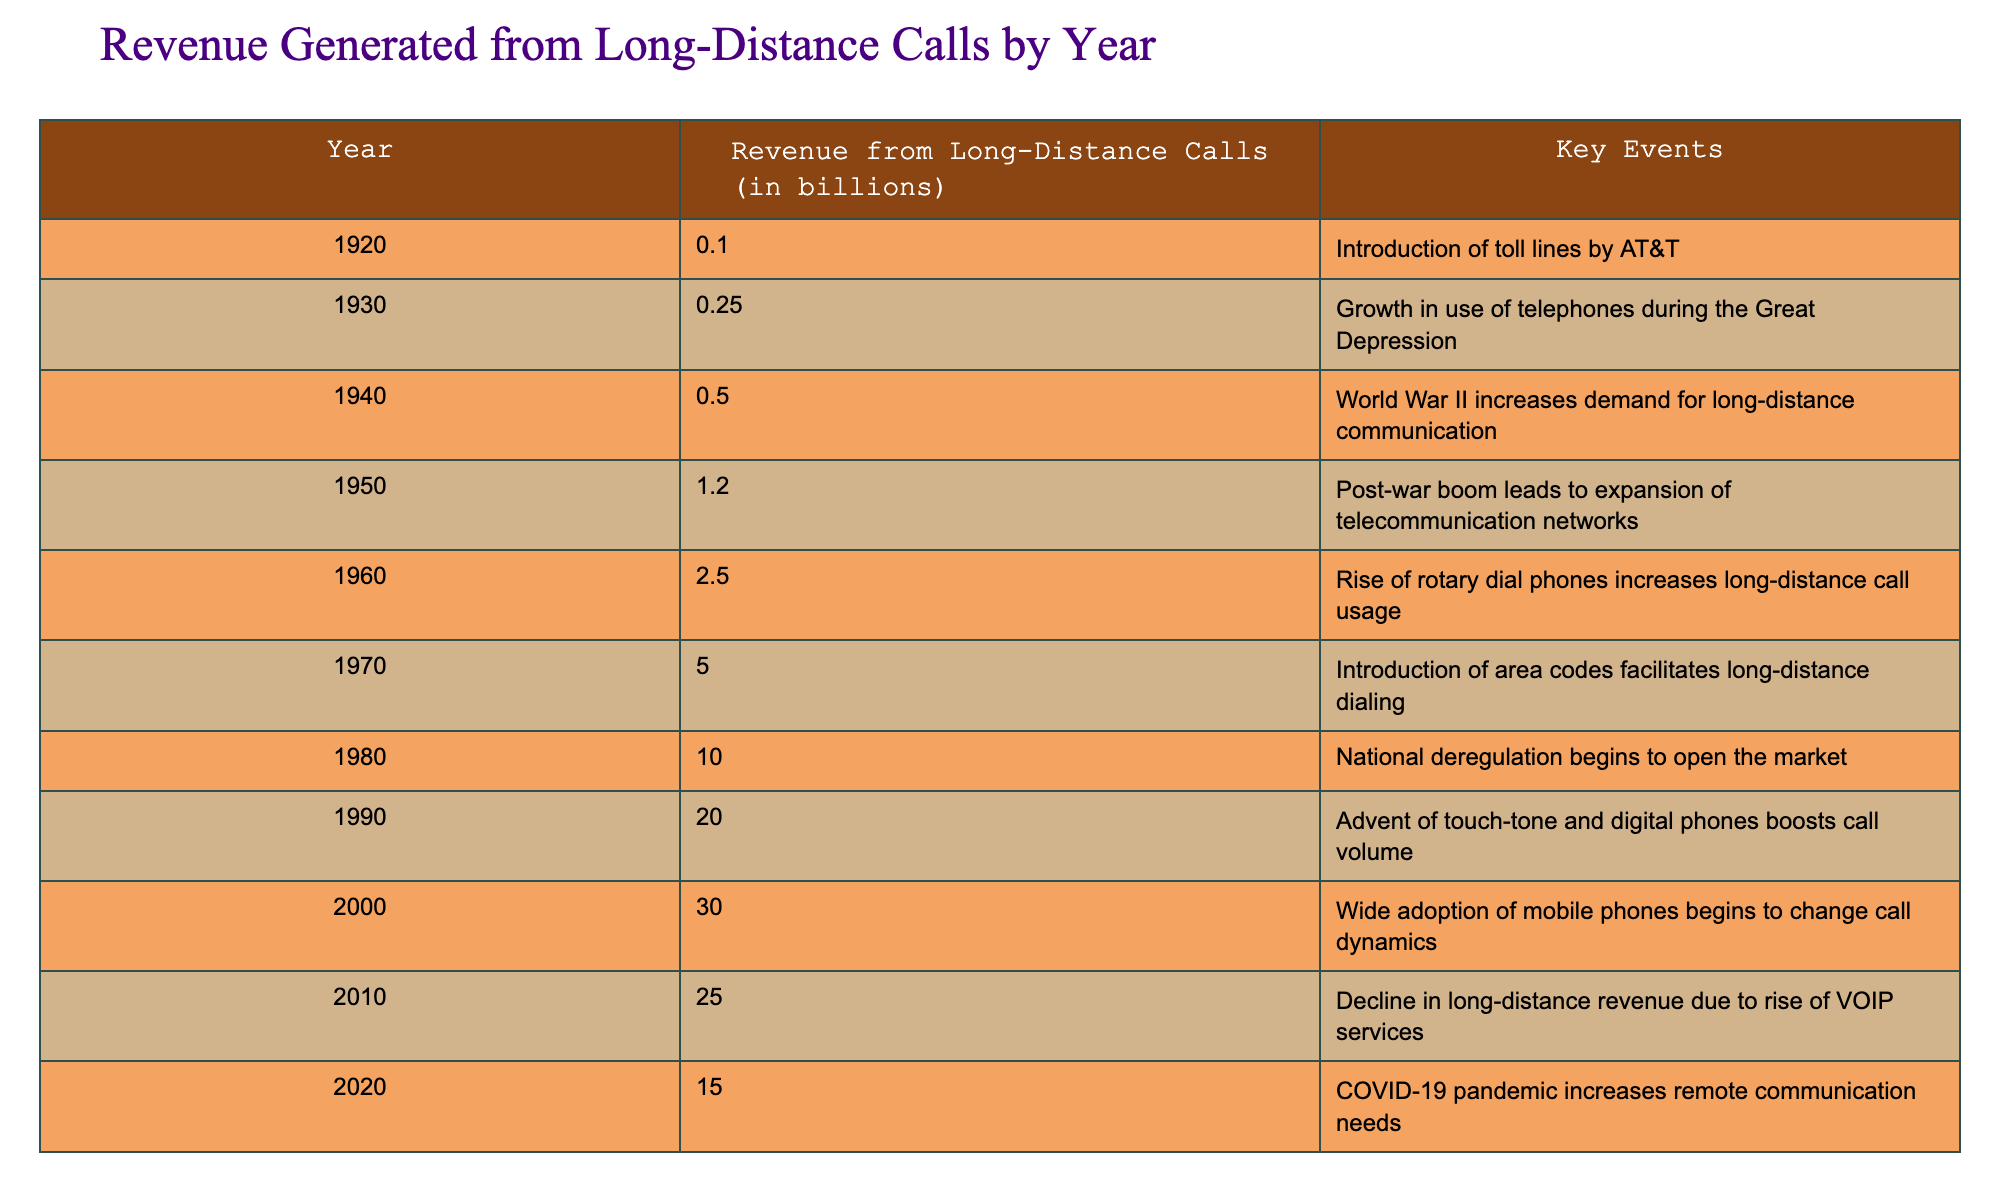What was the revenue from long-distance calls in 1980? According to the table, in 1980, the revenue from long-distance calls was reported to be 10.0 billion.
Answer: 10.0 billion What year saw a revenue of 30.0 billion from long-distance calls? The table indicates that the year 2000 had a revenue of 30.0 billion from long-distance calls.
Answer: 2000 What was the total revenue from long-distance calls generated between 1920 and 1970? To find the total revenue from 1920 to 1970, we sum the revenues from those years: 0.1 + 0.25 + 0.5 + 1.2 + 2.5 + 5.0 = 9.55 billion.
Answer: 9.55 billion Was the revenue from long-distance calls in 2010 higher than in 2020? In 2010, the revenue was 25.0 billion and in 2020, it was 15.0 billion. Since 25.0 billion is greater than 15.0 billion, the statement is true.
Answer: Yes What significant event occurred in 1940 that influenced long-distance communication? The table states that World War II increased the demand for long-distance communication in 1940.
Answer: World War II Did the introduction of area codes in 1970 contribute to an increase in long-distance call revenue? The table shows that in 1970, revenue was 5.0 billion, which is significantly higher than in previous years, suggesting area codes facilitated increased long-distance dialing.
Answer: Yes What is the change in revenue from long-distance calls from 2000 to 2010? Revenue in 2000 was 30.0 billion and in 2010 it fell to 25.0 billion. The change is calculated as 30.0 - 25.0 = 5.0 billion decrease.
Answer: 5.0 billion decrease Which years saw a drop in long-distance call revenue compared to the previous year, and what was the amount for each? In 2010, the revenue dropped from 30.0 billion in 2000 to 25.0 billion, amounting to a 5.0 billion decrease. In 2020, it decreased further to 15.0 billion, resulting in a 10.0 billion decrease from 2010.
Answer: 2010 (5.0 billion decrease), 2020 (10.0 billion decrease) By what percentage did revenue increase from 1920 to 1960? The revenue in 1920 was 0.1 billion and in 1960 it was 2.5 billion. The increase is 2.5 - 0.1 = 2.4 billion. To find the percentage increase: (2.4 / 0.1) * 100 = 2400%.
Answer: 2400% 